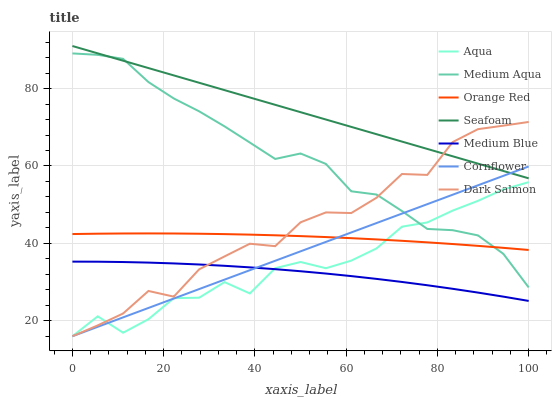Does Aqua have the minimum area under the curve?
Answer yes or no. No. Does Aqua have the maximum area under the curve?
Answer yes or no. No. Is Aqua the smoothest?
Answer yes or no. No. Is Aqua the roughest?
Answer yes or no. No. Does Medium Blue have the lowest value?
Answer yes or no. No. Does Aqua have the highest value?
Answer yes or no. No. Is Medium Blue less than Orange Red?
Answer yes or no. Yes. Is Seafoam greater than Medium Blue?
Answer yes or no. Yes. Does Medium Blue intersect Orange Red?
Answer yes or no. No. 